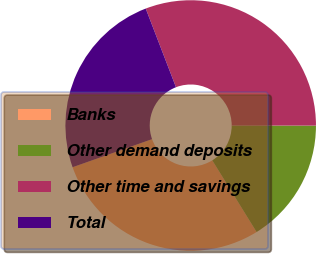<chart> <loc_0><loc_0><loc_500><loc_500><pie_chart><fcel>Banks<fcel>Other demand deposits<fcel>Other time and savings<fcel>Total<nl><fcel>28.41%<fcel>16.17%<fcel>30.86%<fcel>24.56%<nl></chart> 